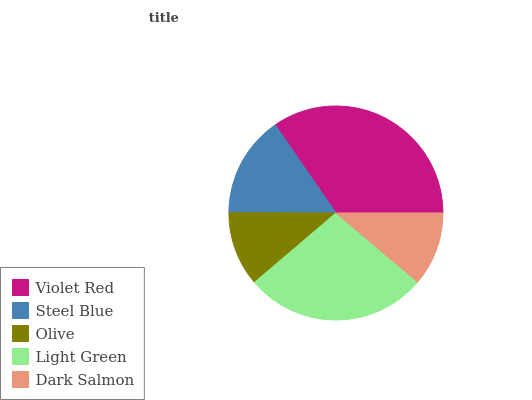Is Dark Salmon the minimum?
Answer yes or no. Yes. Is Violet Red the maximum?
Answer yes or no. Yes. Is Steel Blue the minimum?
Answer yes or no. No. Is Steel Blue the maximum?
Answer yes or no. No. Is Violet Red greater than Steel Blue?
Answer yes or no. Yes. Is Steel Blue less than Violet Red?
Answer yes or no. Yes. Is Steel Blue greater than Violet Red?
Answer yes or no. No. Is Violet Red less than Steel Blue?
Answer yes or no. No. Is Steel Blue the high median?
Answer yes or no. Yes. Is Steel Blue the low median?
Answer yes or no. Yes. Is Light Green the high median?
Answer yes or no. No. Is Light Green the low median?
Answer yes or no. No. 